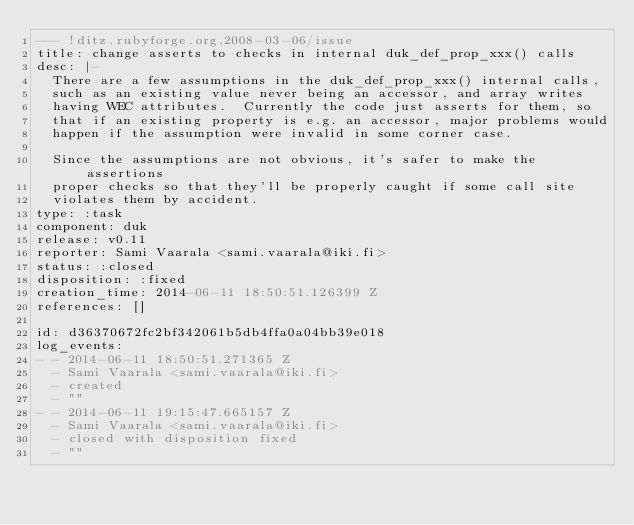<code> <loc_0><loc_0><loc_500><loc_500><_YAML_>--- !ditz.rubyforge.org,2008-03-06/issue 
title: change asserts to checks in internal duk_def_prop_xxx() calls
desc: |-
  There are a few assumptions in the duk_def_prop_xxx() internal calls,
  such as an existing value never being an accessor, and array writes
  having WEC attributes.  Currently the code just asserts for them, so
  that if an existing property is e.g. an accessor, major problems would
  happen if the assumption were invalid in some corner case.
  
  Since the assumptions are not obvious, it's safer to make the assertions
  proper checks so that they'll be properly caught if some call site
  violates them by accident.
type: :task
component: duk
release: v0.11
reporter: Sami Vaarala <sami.vaarala@iki.fi>
status: :closed
disposition: :fixed
creation_time: 2014-06-11 18:50:51.126399 Z
references: []

id: d36370672fc2bf342061b5db4ffa0a04bb39e018
log_events: 
- - 2014-06-11 18:50:51.271365 Z
  - Sami Vaarala <sami.vaarala@iki.fi>
  - created
  - ""
- - 2014-06-11 19:15:47.665157 Z
  - Sami Vaarala <sami.vaarala@iki.fi>
  - closed with disposition fixed
  - ""
</code> 